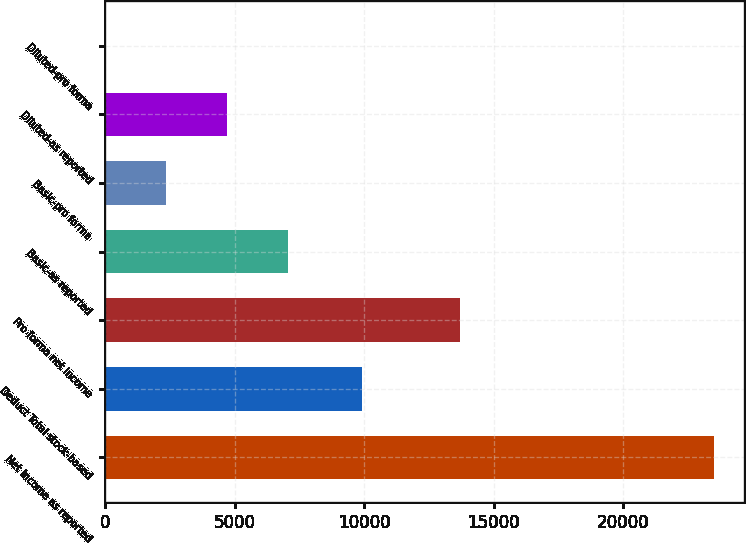<chart> <loc_0><loc_0><loc_500><loc_500><bar_chart><fcel>Net income as reported<fcel>Deduct Total stock-based<fcel>Pro forma net income<fcel>Basic-as reported<fcel>Basic-pro forma<fcel>Diluted-as reported<fcel>Diluted-pro forma<nl><fcel>23478<fcel>9916<fcel>13709<fcel>7043.67<fcel>2348.15<fcel>4695.91<fcel>0.39<nl></chart> 